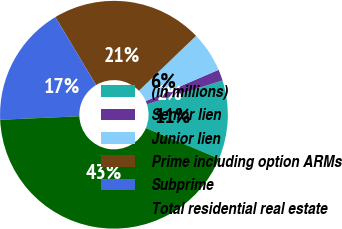Convert chart. <chart><loc_0><loc_0><loc_500><loc_500><pie_chart><fcel>(in millions)<fcel>Senior lien<fcel>Junior lien<fcel>Prime including option ARMs<fcel>Subprime<fcel>Total residential real estate<nl><fcel>11.16%<fcel>1.59%<fcel>5.73%<fcel>21.41%<fcel>17.11%<fcel>43.0%<nl></chart> 